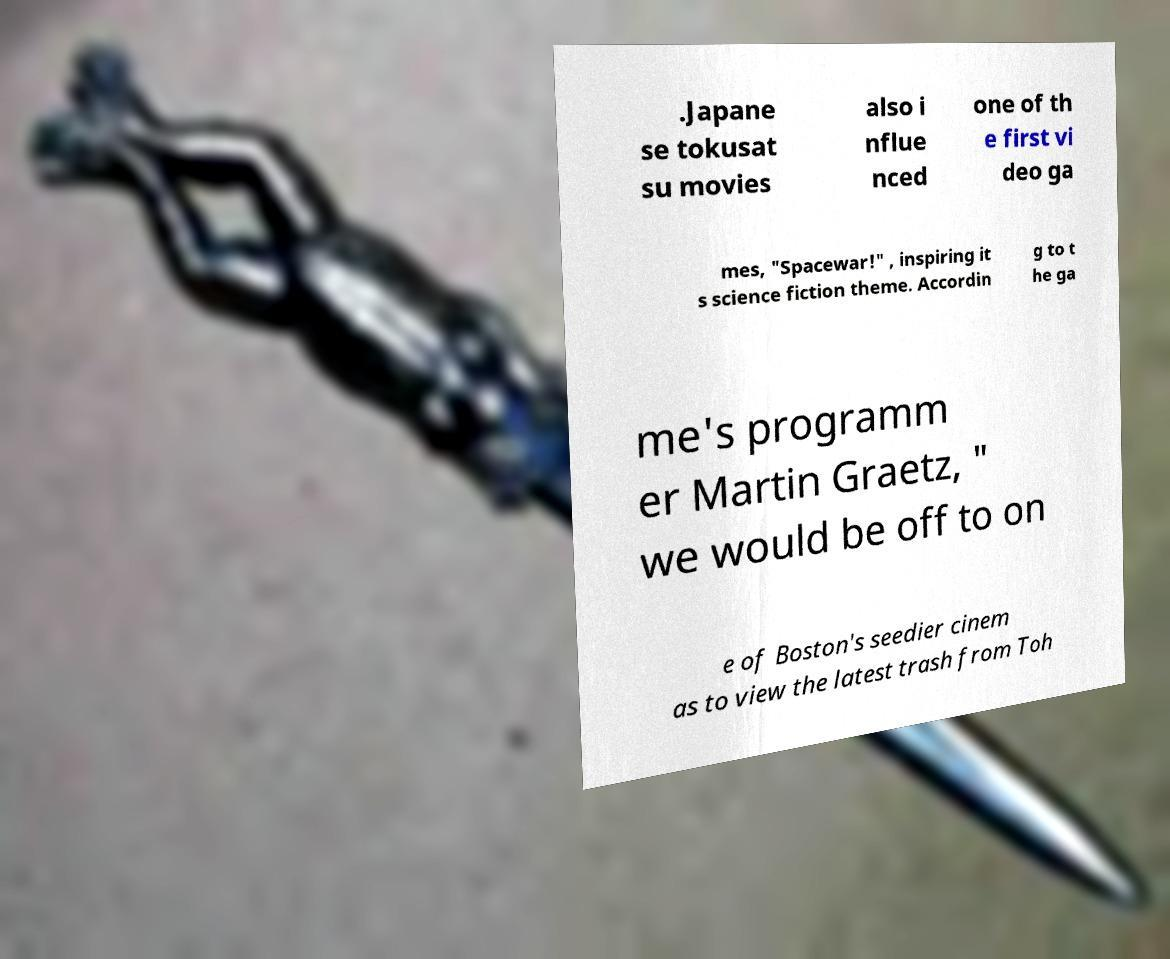Could you extract and type out the text from this image? .Japane se tokusat su movies also i nflue nced one of th e first vi deo ga mes, "Spacewar!" , inspiring it s science fiction theme. Accordin g to t he ga me's programm er Martin Graetz, " we would be off to on e of Boston's seedier cinem as to view the latest trash from Toh 